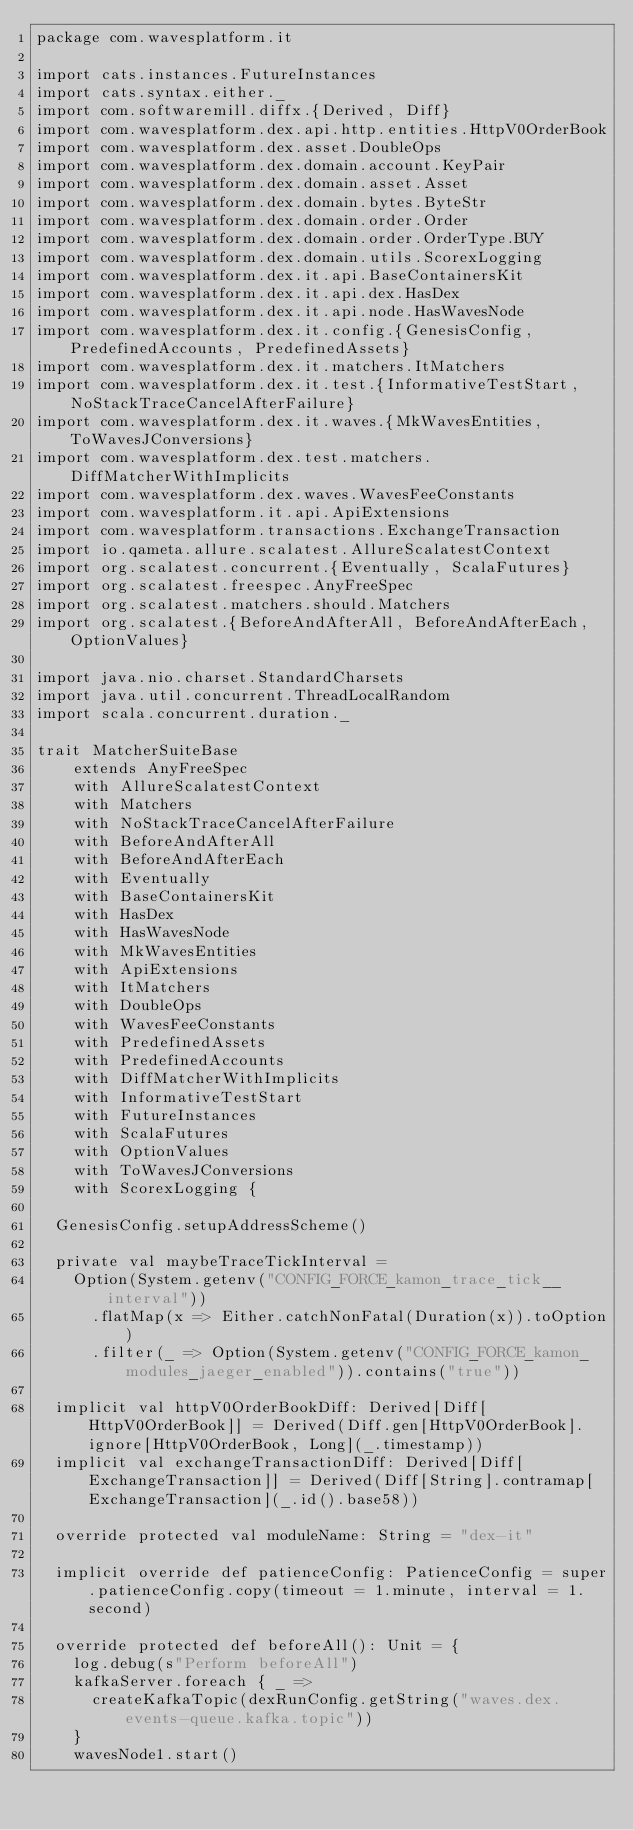Convert code to text. <code><loc_0><loc_0><loc_500><loc_500><_Scala_>package com.wavesplatform.it

import cats.instances.FutureInstances
import cats.syntax.either._
import com.softwaremill.diffx.{Derived, Diff}
import com.wavesplatform.dex.api.http.entities.HttpV0OrderBook
import com.wavesplatform.dex.asset.DoubleOps
import com.wavesplatform.dex.domain.account.KeyPair
import com.wavesplatform.dex.domain.asset.Asset
import com.wavesplatform.dex.domain.bytes.ByteStr
import com.wavesplatform.dex.domain.order.Order
import com.wavesplatform.dex.domain.order.OrderType.BUY
import com.wavesplatform.dex.domain.utils.ScorexLogging
import com.wavesplatform.dex.it.api.BaseContainersKit
import com.wavesplatform.dex.it.api.dex.HasDex
import com.wavesplatform.dex.it.api.node.HasWavesNode
import com.wavesplatform.dex.it.config.{GenesisConfig, PredefinedAccounts, PredefinedAssets}
import com.wavesplatform.dex.it.matchers.ItMatchers
import com.wavesplatform.dex.it.test.{InformativeTestStart, NoStackTraceCancelAfterFailure}
import com.wavesplatform.dex.it.waves.{MkWavesEntities, ToWavesJConversions}
import com.wavesplatform.dex.test.matchers.DiffMatcherWithImplicits
import com.wavesplatform.dex.waves.WavesFeeConstants
import com.wavesplatform.it.api.ApiExtensions
import com.wavesplatform.transactions.ExchangeTransaction
import io.qameta.allure.scalatest.AllureScalatestContext
import org.scalatest.concurrent.{Eventually, ScalaFutures}
import org.scalatest.freespec.AnyFreeSpec
import org.scalatest.matchers.should.Matchers
import org.scalatest.{BeforeAndAfterAll, BeforeAndAfterEach, OptionValues}

import java.nio.charset.StandardCharsets
import java.util.concurrent.ThreadLocalRandom
import scala.concurrent.duration._

trait MatcherSuiteBase
    extends AnyFreeSpec
    with AllureScalatestContext
    with Matchers
    with NoStackTraceCancelAfterFailure
    with BeforeAndAfterAll
    with BeforeAndAfterEach
    with Eventually
    with BaseContainersKit
    with HasDex
    with HasWavesNode
    with MkWavesEntities
    with ApiExtensions
    with ItMatchers
    with DoubleOps
    with WavesFeeConstants
    with PredefinedAssets
    with PredefinedAccounts
    with DiffMatcherWithImplicits
    with InformativeTestStart
    with FutureInstances
    with ScalaFutures
    with OptionValues
    with ToWavesJConversions
    with ScorexLogging {

  GenesisConfig.setupAddressScheme()

  private val maybeTraceTickInterval =
    Option(System.getenv("CONFIG_FORCE_kamon_trace_tick__interval"))
      .flatMap(x => Either.catchNonFatal(Duration(x)).toOption)
      .filter(_ => Option(System.getenv("CONFIG_FORCE_kamon_modules_jaeger_enabled")).contains("true"))

  implicit val httpV0OrderBookDiff: Derived[Diff[HttpV0OrderBook]] = Derived(Diff.gen[HttpV0OrderBook].ignore[HttpV0OrderBook, Long](_.timestamp))
  implicit val exchangeTransactionDiff: Derived[Diff[ExchangeTransaction]] = Derived(Diff[String].contramap[ExchangeTransaction](_.id().base58))

  override protected val moduleName: String = "dex-it"

  implicit override def patienceConfig: PatienceConfig = super.patienceConfig.copy(timeout = 1.minute, interval = 1.second)

  override protected def beforeAll(): Unit = {
    log.debug(s"Perform beforeAll")
    kafkaServer.foreach { _ =>
      createKafkaTopic(dexRunConfig.getString("waves.dex.events-queue.kafka.topic"))
    }
    wavesNode1.start()</code> 